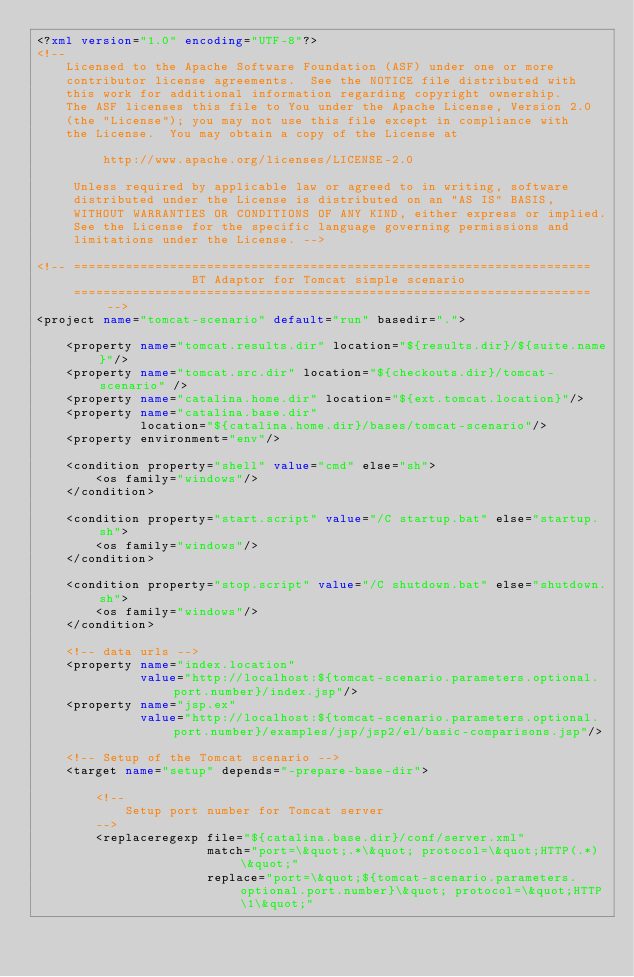<code> <loc_0><loc_0><loc_500><loc_500><_XML_><?xml version="1.0" encoding="UTF-8"?>
<!-- 
    Licensed to the Apache Software Foundation (ASF) under one or more
    contributor license agreements.  See the NOTICE file distributed with
    this work for additional information regarding copyright ownership.
    The ASF licenses this file to You under the Apache License, Version 2.0
    (the "License"); you may not use this file except in compliance with
    the License.  You may obtain a copy of the License at
     
         http://www.apache.org/licenses/LICENSE-2.0
     
     Unless required by applicable law or agreed to in writing, software
     distributed under the License is distributed on an "AS IS" BASIS,
     WITHOUT WARRANTIES OR CONDITIONS OF ANY KIND, either express or implied.
     See the License for the specific language governing permissions and
     limitations under the License. -->

<!-- ======================================================================
                     BT Adaptor for Tomcat simple scenario
     ====================================================================== -->
<project name="tomcat-scenario" default="run" basedir=".">

    <property name="tomcat.results.dir" location="${results.dir}/${suite.name}"/>
    <property name="tomcat.src.dir" location="${checkouts.dir}/tomcat-scenario" />
    <property name="catalina.home.dir" location="${ext.tomcat.location}"/>
    <property name="catalina.base.dir"
              location="${catalina.home.dir}/bases/tomcat-scenario"/>
    <property environment="env"/>

    <condition property="shell" value="cmd" else="sh">
        <os family="windows"/>
    </condition>

    <condition property="start.script" value="/C startup.bat" else="startup.sh">
        <os family="windows"/>
    </condition>

    <condition property="stop.script" value="/C shutdown.bat" else="shutdown.sh">
        <os family="windows"/>
    </condition>

    <!-- data urls -->
    <property name="index.location"
              value="http://localhost:${tomcat-scenario.parameters.optional.port.number}/index.jsp"/>
    <property name="jsp.ex"
              value="http://localhost:${tomcat-scenario.parameters.optional.port.number}/examples/jsp/jsp2/el/basic-comparisons.jsp"/>

    <!-- Setup of the Tomcat scenario -->
    <target name="setup" depends="-prepare-base-dir">
        
        <!--
            Setup port number for Tomcat server
        -->
        <replaceregexp file="${catalina.base.dir}/conf/server.xml"
                       match="port=\&quot;.*\&quot; protocol=\&quot;HTTP(.*)\&quot;"
                       replace="port=\&quot;${tomcat-scenario.parameters.optional.port.number}\&quot; protocol=\&quot;HTTP\1\&quot;"</code> 